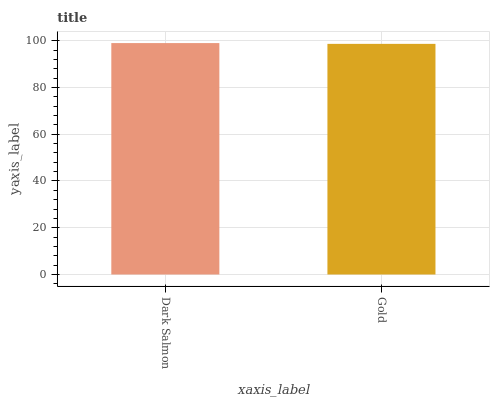Is Gold the maximum?
Answer yes or no. No. Is Dark Salmon greater than Gold?
Answer yes or no. Yes. Is Gold less than Dark Salmon?
Answer yes or no. Yes. Is Gold greater than Dark Salmon?
Answer yes or no. No. Is Dark Salmon less than Gold?
Answer yes or no. No. Is Dark Salmon the high median?
Answer yes or no. Yes. Is Gold the low median?
Answer yes or no. Yes. Is Gold the high median?
Answer yes or no. No. Is Dark Salmon the low median?
Answer yes or no. No. 